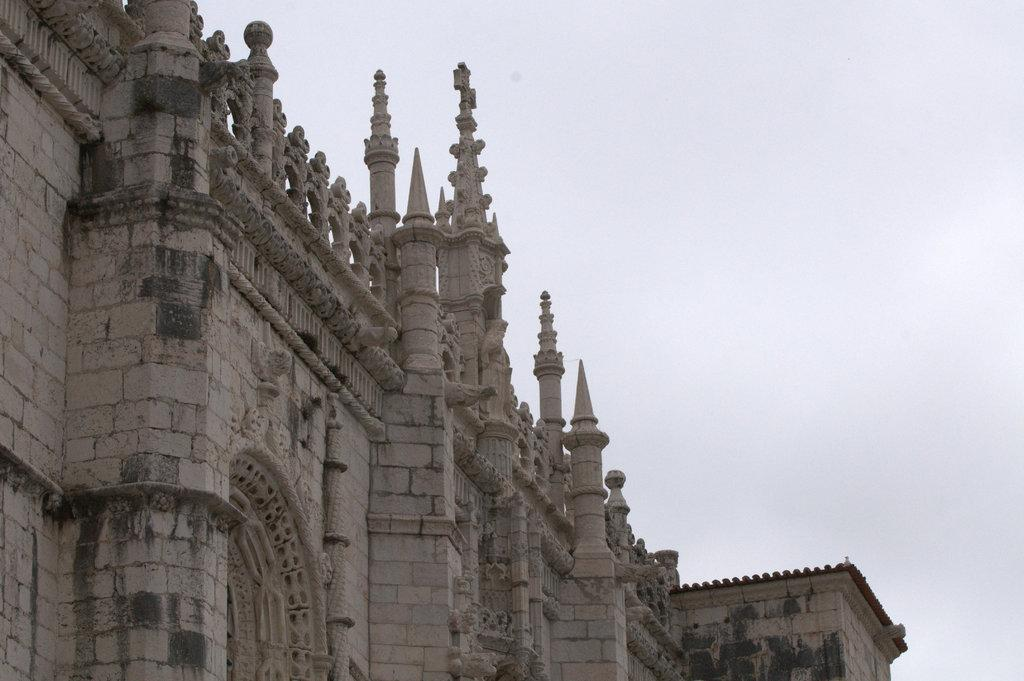What is the main subject in the picture? There is a building in the picture. What can be seen in the background of the picture? The sky is visible in the background of the picture. What type of love is being expressed by the manager in the basket in the image? There is no mention of love, a manager, or a basket in the image; it only features a building and the sky. 